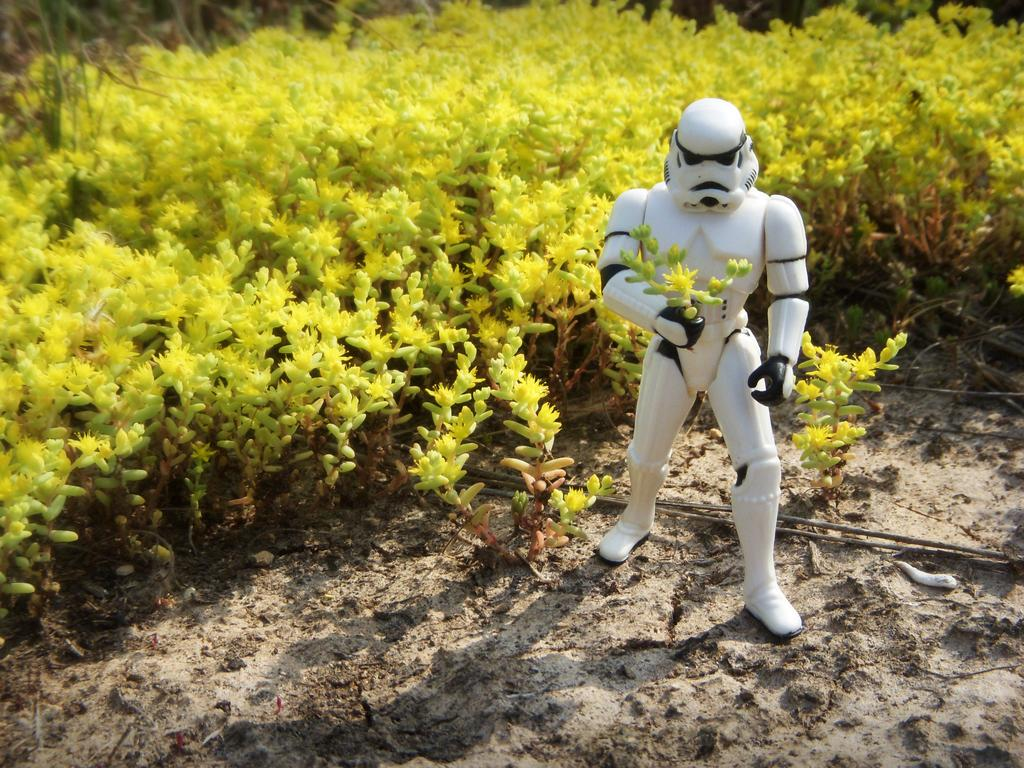What type of object is the main subject in the image? There is a white toy in the image. What can be seen in the background of the image? There are plants in the background of the image. What is the color of the plants in the image? The plants are green in color. What type of committee can be seen discussing the scarecrow in the image? There is no committee or scarecrow present in the image; it features a white toy and green plants in the background. How many chickens are visible in the image? There are no chickens present in the image. 